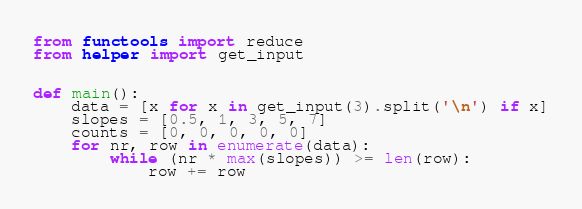Convert code to text. <code><loc_0><loc_0><loc_500><loc_500><_Python_>from functools import reduce
from helper import get_input


def main():
    data = [x for x in get_input(3).split('\n') if x]
    slopes = [0.5, 1, 3, 5, 7]
    counts = [0, 0, 0, 0, 0]
    for nr, row in enumerate(data):
        while (nr * max(slopes)) >= len(row):
            row += row</code> 